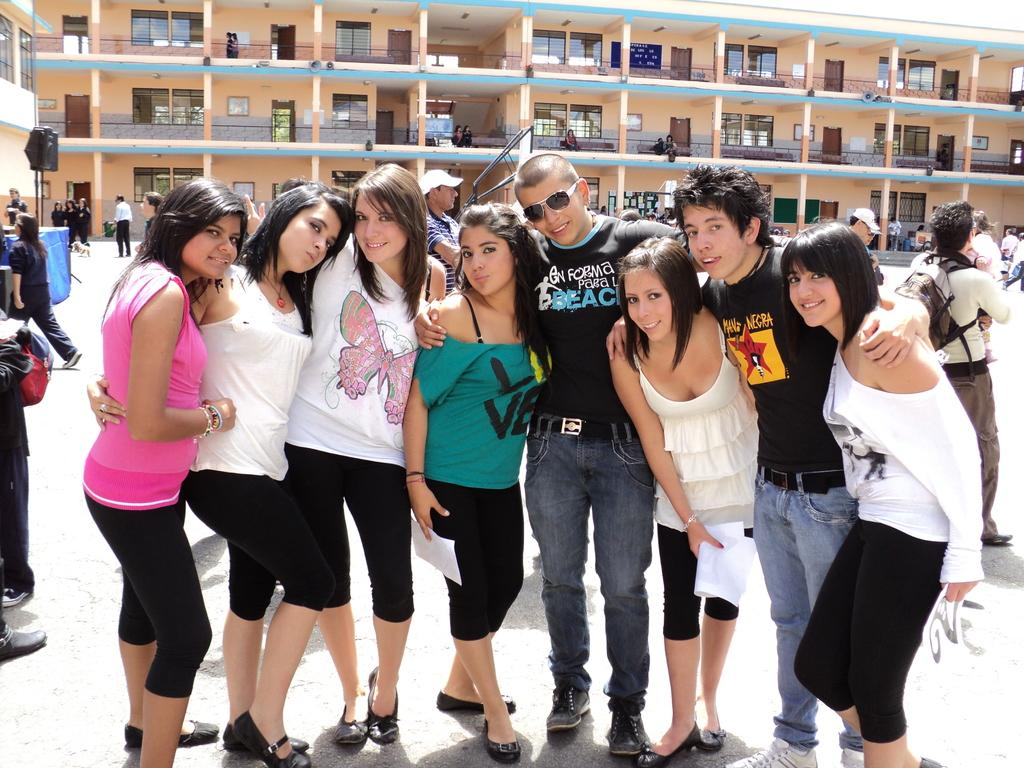Who is present in the image? There are boys and girls in the image. What type of structure is visible in the image? There is a building with windows and doors in the image. What object can be seen in the image that might be related to learning or communication? There is a paper in the image. How many pies are being served on the top of the building in the image? There are no pies visible in the image, and the image does not show the top of the building. 